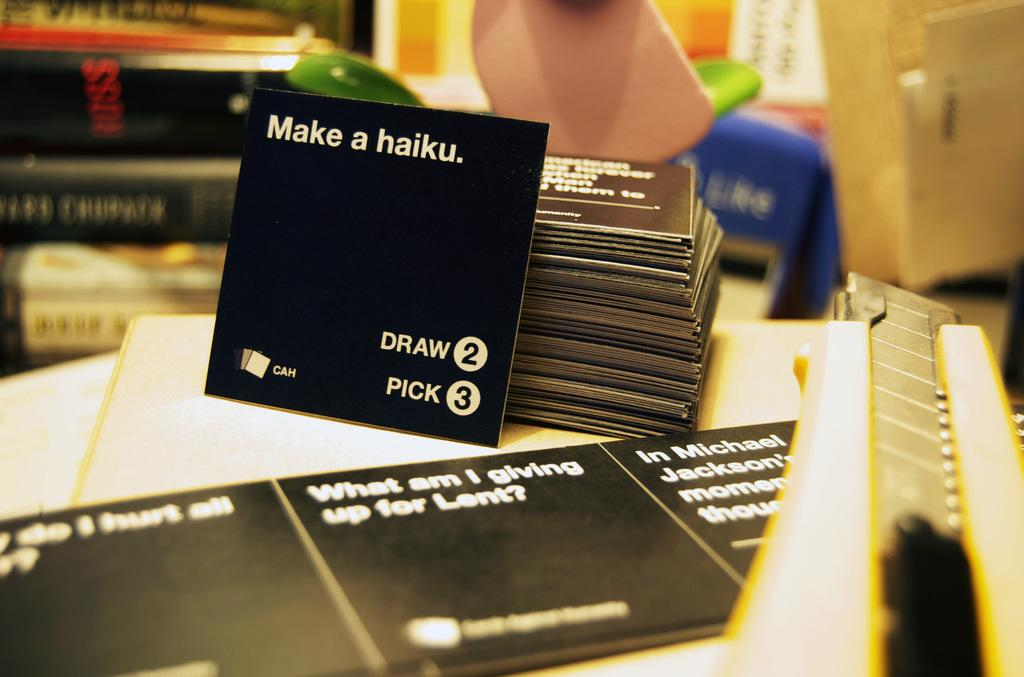Provide a one-sentence caption for the provided image. A black card that instructs somebody to draw 2 and pick 3. 